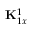<formula> <loc_0><loc_0><loc_500><loc_500>{ K } _ { 1 x } ^ { 1 }</formula> 